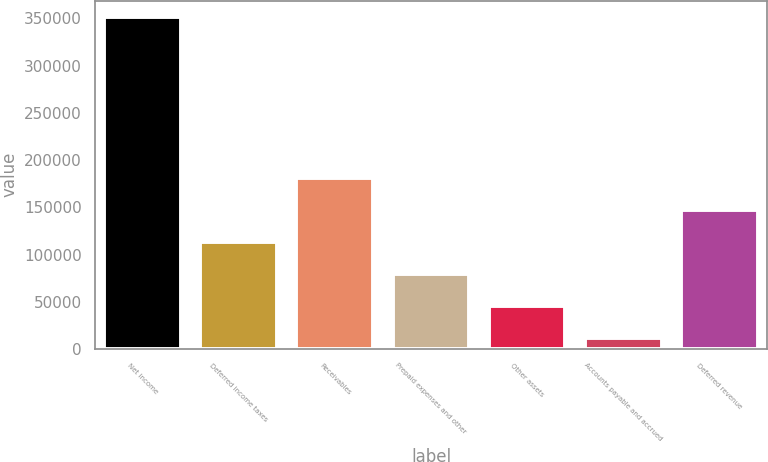Convert chart to OTSL. <chart><loc_0><loc_0><loc_500><loc_500><bar_chart><fcel>Net income<fcel>Deferred income taxes<fcel>Receivables<fcel>Prepaid expenses and other<fcel>Other assets<fcel>Accounts payable and accrued<fcel>Deferred revenue<nl><fcel>351297<fcel>113546<fcel>181475<fcel>79581.8<fcel>45617.4<fcel>11653<fcel>147511<nl></chart> 